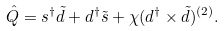Convert formula to latex. <formula><loc_0><loc_0><loc_500><loc_500>\hat { Q } = s ^ { \dag } \tilde { d } + d ^ { \dag } \tilde { s } + \chi ( d ^ { \dag } \times \tilde { d } ) ^ { ( 2 ) } .</formula> 